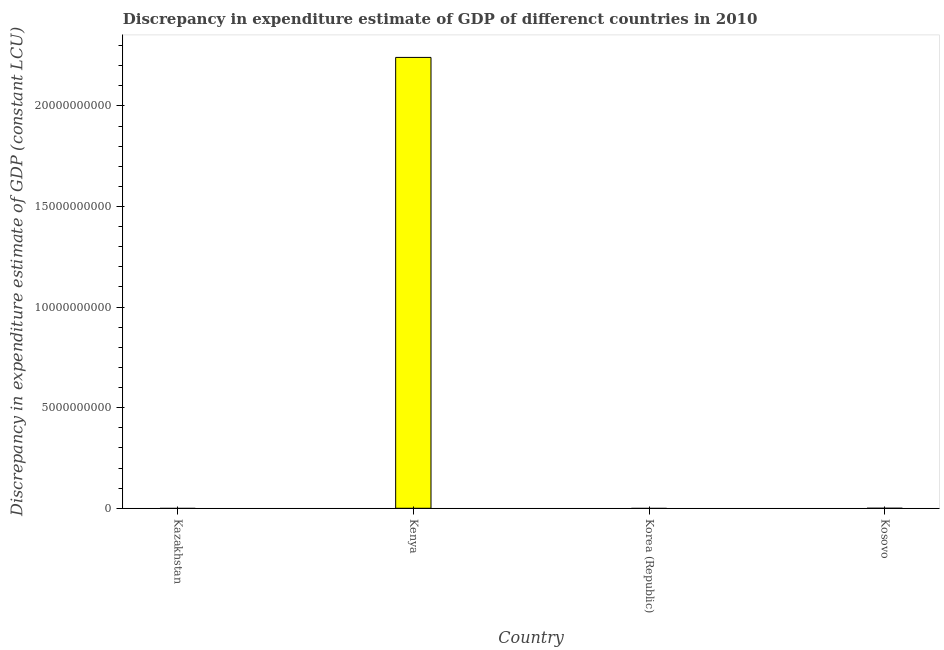Does the graph contain any zero values?
Your answer should be very brief. Yes. What is the title of the graph?
Offer a very short reply. Discrepancy in expenditure estimate of GDP of differenct countries in 2010. What is the label or title of the Y-axis?
Your answer should be very brief. Discrepancy in expenditure estimate of GDP (constant LCU). What is the discrepancy in expenditure estimate of gdp in Kenya?
Provide a succinct answer. 2.24e+1. Across all countries, what is the maximum discrepancy in expenditure estimate of gdp?
Offer a terse response. 2.24e+1. In which country was the discrepancy in expenditure estimate of gdp maximum?
Keep it short and to the point. Kenya. What is the sum of the discrepancy in expenditure estimate of gdp?
Your response must be concise. 2.24e+1. What is the average discrepancy in expenditure estimate of gdp per country?
Your answer should be compact. 5.60e+09. What is the median discrepancy in expenditure estimate of gdp?
Ensure brevity in your answer.  1.00e+05. In how many countries, is the discrepancy in expenditure estimate of gdp greater than 2000000000 LCU?
Keep it short and to the point. 1. What is the difference between the highest and the lowest discrepancy in expenditure estimate of gdp?
Give a very brief answer. 2.24e+1. Are all the bars in the graph horizontal?
Your response must be concise. No. How many countries are there in the graph?
Offer a very short reply. 4. What is the Discrepancy in expenditure estimate of GDP (constant LCU) in Kenya?
Keep it short and to the point. 2.24e+1. What is the Discrepancy in expenditure estimate of GDP (constant LCU) of Kosovo?
Offer a terse response. 2.00e+05. What is the difference between the Discrepancy in expenditure estimate of GDP (constant LCU) in Kenya and Kosovo?
Make the answer very short. 2.24e+1. What is the ratio of the Discrepancy in expenditure estimate of GDP (constant LCU) in Kenya to that in Kosovo?
Offer a very short reply. 1.12e+05. 